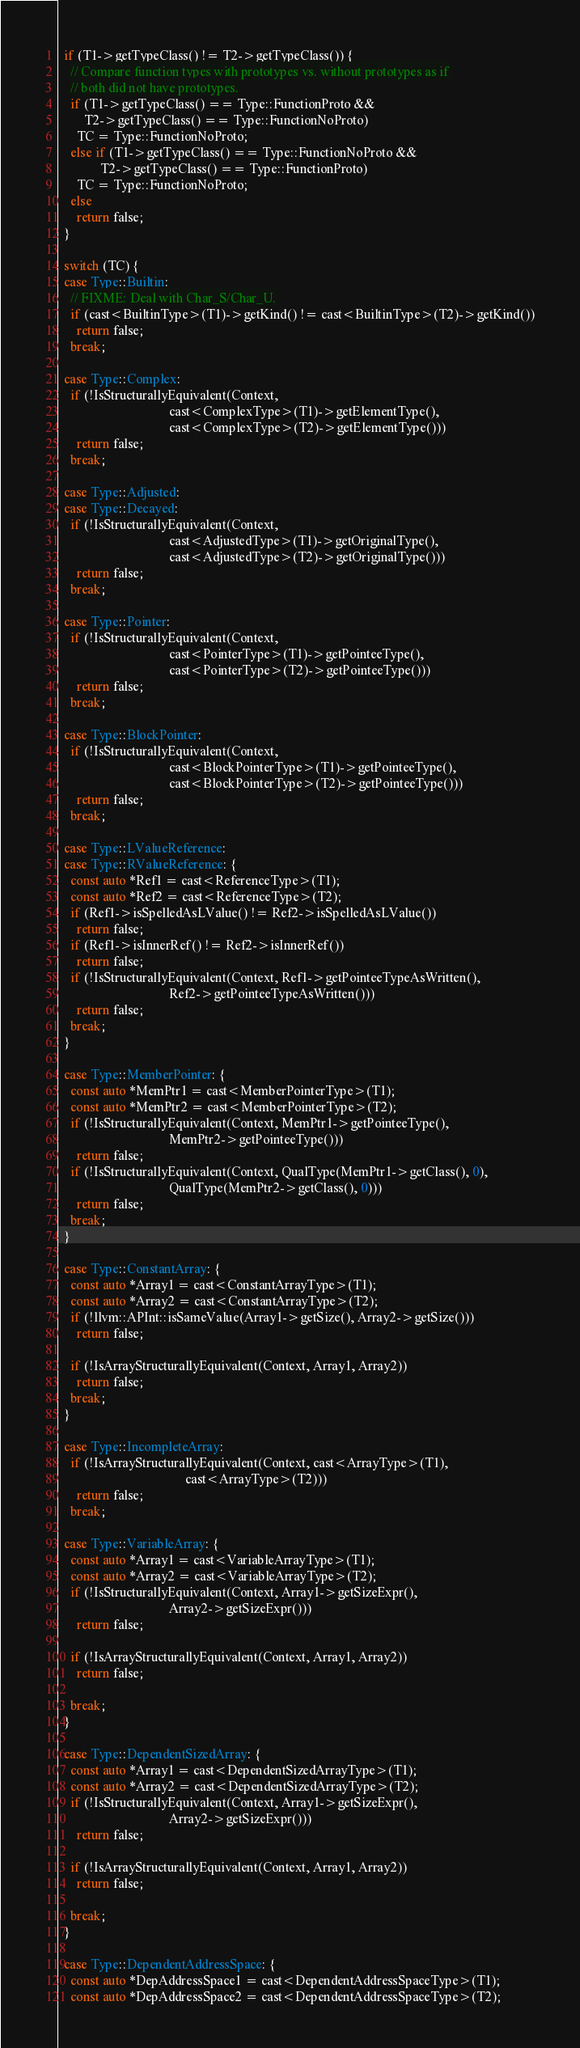<code> <loc_0><loc_0><loc_500><loc_500><_C++_>
  if (T1->getTypeClass() != T2->getTypeClass()) {
    // Compare function types with prototypes vs. without prototypes as if
    // both did not have prototypes.
    if (T1->getTypeClass() == Type::FunctionProto &&
        T2->getTypeClass() == Type::FunctionNoProto)
      TC = Type::FunctionNoProto;
    else if (T1->getTypeClass() == Type::FunctionNoProto &&
             T2->getTypeClass() == Type::FunctionProto)
      TC = Type::FunctionNoProto;
    else
      return false;
  }

  switch (TC) {
  case Type::Builtin:
    // FIXME: Deal with Char_S/Char_U.
    if (cast<BuiltinType>(T1)->getKind() != cast<BuiltinType>(T2)->getKind())
      return false;
    break;

  case Type::Complex:
    if (!IsStructurallyEquivalent(Context,
                                  cast<ComplexType>(T1)->getElementType(),
                                  cast<ComplexType>(T2)->getElementType()))
      return false;
    break;

  case Type::Adjusted:
  case Type::Decayed:
    if (!IsStructurallyEquivalent(Context,
                                  cast<AdjustedType>(T1)->getOriginalType(),
                                  cast<AdjustedType>(T2)->getOriginalType()))
      return false;
    break;

  case Type::Pointer:
    if (!IsStructurallyEquivalent(Context,
                                  cast<PointerType>(T1)->getPointeeType(),
                                  cast<PointerType>(T2)->getPointeeType()))
      return false;
    break;

  case Type::BlockPointer:
    if (!IsStructurallyEquivalent(Context,
                                  cast<BlockPointerType>(T1)->getPointeeType(),
                                  cast<BlockPointerType>(T2)->getPointeeType()))
      return false;
    break;

  case Type::LValueReference:
  case Type::RValueReference: {
    const auto *Ref1 = cast<ReferenceType>(T1);
    const auto *Ref2 = cast<ReferenceType>(T2);
    if (Ref1->isSpelledAsLValue() != Ref2->isSpelledAsLValue())
      return false;
    if (Ref1->isInnerRef() != Ref2->isInnerRef())
      return false;
    if (!IsStructurallyEquivalent(Context, Ref1->getPointeeTypeAsWritten(),
                                  Ref2->getPointeeTypeAsWritten()))
      return false;
    break;
  }

  case Type::MemberPointer: {
    const auto *MemPtr1 = cast<MemberPointerType>(T1);
    const auto *MemPtr2 = cast<MemberPointerType>(T2);
    if (!IsStructurallyEquivalent(Context, MemPtr1->getPointeeType(),
                                  MemPtr2->getPointeeType()))
      return false;
    if (!IsStructurallyEquivalent(Context, QualType(MemPtr1->getClass(), 0),
                                  QualType(MemPtr2->getClass(), 0)))
      return false;
    break;
  }

  case Type::ConstantArray: {
    const auto *Array1 = cast<ConstantArrayType>(T1);
    const auto *Array2 = cast<ConstantArrayType>(T2);
    if (!llvm::APInt::isSameValue(Array1->getSize(), Array2->getSize()))
      return false;

    if (!IsArrayStructurallyEquivalent(Context, Array1, Array2))
      return false;
    break;
  }

  case Type::IncompleteArray:
    if (!IsArrayStructurallyEquivalent(Context, cast<ArrayType>(T1),
                                       cast<ArrayType>(T2)))
      return false;
    break;

  case Type::VariableArray: {
    const auto *Array1 = cast<VariableArrayType>(T1);
    const auto *Array2 = cast<VariableArrayType>(T2);
    if (!IsStructurallyEquivalent(Context, Array1->getSizeExpr(),
                                  Array2->getSizeExpr()))
      return false;

    if (!IsArrayStructurallyEquivalent(Context, Array1, Array2))
      return false;

    break;
  }

  case Type::DependentSizedArray: {
    const auto *Array1 = cast<DependentSizedArrayType>(T1);
    const auto *Array2 = cast<DependentSizedArrayType>(T2);
    if (!IsStructurallyEquivalent(Context, Array1->getSizeExpr(),
                                  Array2->getSizeExpr()))
      return false;

    if (!IsArrayStructurallyEquivalent(Context, Array1, Array2))
      return false;

    break;
  }

  case Type::DependentAddressSpace: {
    const auto *DepAddressSpace1 = cast<DependentAddressSpaceType>(T1);
    const auto *DepAddressSpace2 = cast<DependentAddressSpaceType>(T2);</code> 